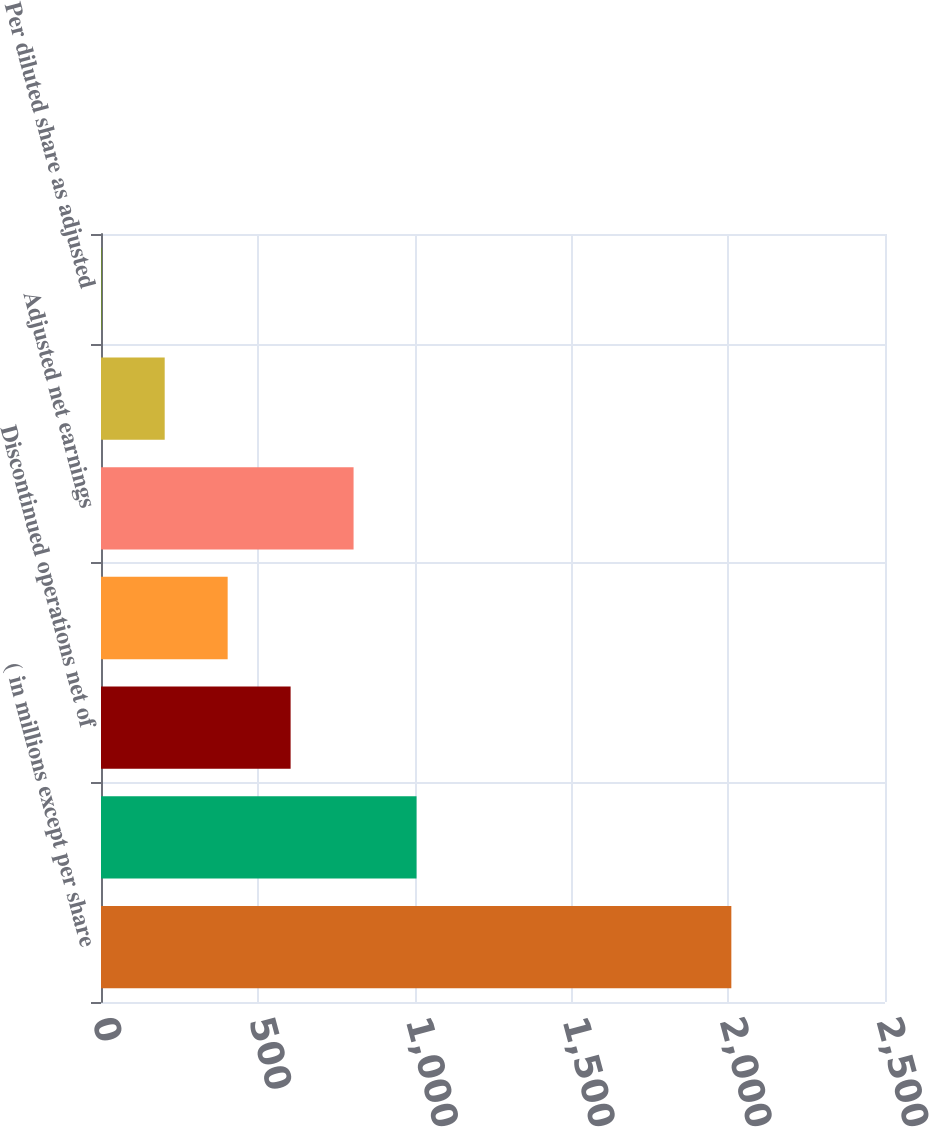Convert chart. <chart><loc_0><loc_0><loc_500><loc_500><bar_chart><fcel>( in millions except per share<fcel>Net earnings attributable to<fcel>Discontinued operations net of<fcel>Business consolidation<fcel>Adjusted net earnings<fcel>Per diluted share from<fcel>Per diluted share as adjusted<nl><fcel>2010<fcel>1006.16<fcel>604.64<fcel>403.88<fcel>805.4<fcel>203.12<fcel>2.36<nl></chart> 